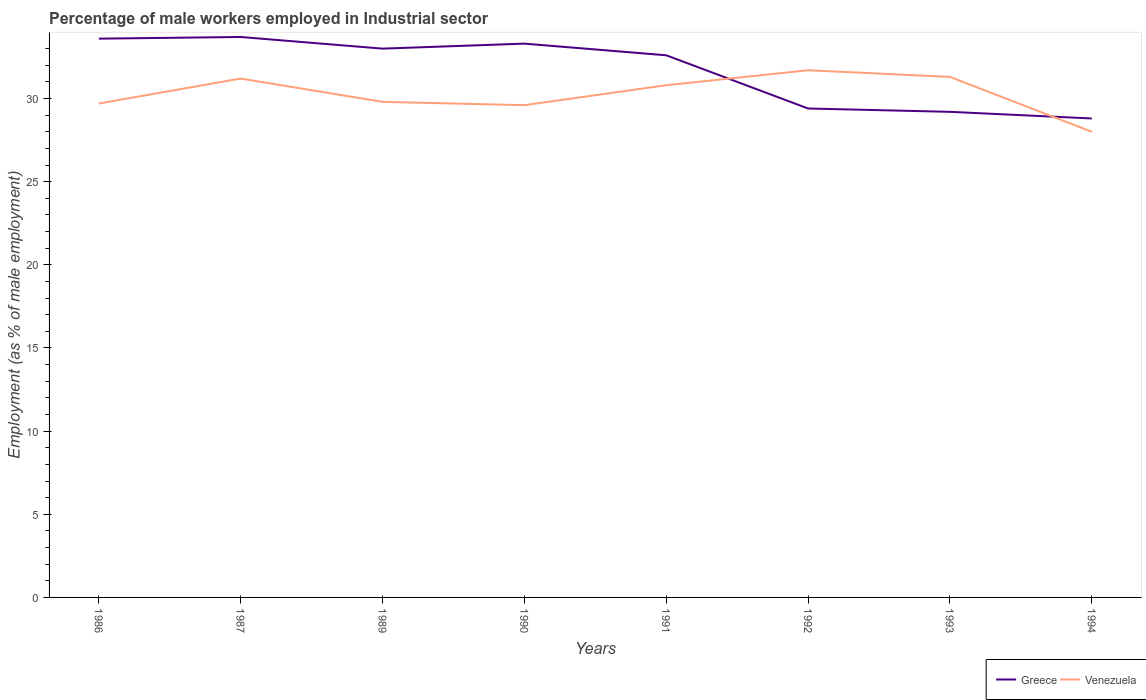Is the number of lines equal to the number of legend labels?
Offer a very short reply. Yes. Across all years, what is the maximum percentage of male workers employed in Industrial sector in Venezuela?
Offer a very short reply. 28. In which year was the percentage of male workers employed in Industrial sector in Greece maximum?
Offer a terse response. 1994. What is the total percentage of male workers employed in Industrial sector in Greece in the graph?
Provide a short and direct response. 0.7. What is the difference between the highest and the second highest percentage of male workers employed in Industrial sector in Venezuela?
Your answer should be very brief. 3.7. What is the difference between the highest and the lowest percentage of male workers employed in Industrial sector in Venezuela?
Provide a succinct answer. 4. Is the percentage of male workers employed in Industrial sector in Venezuela strictly greater than the percentage of male workers employed in Industrial sector in Greece over the years?
Provide a succinct answer. No. What is the difference between two consecutive major ticks on the Y-axis?
Keep it short and to the point. 5. Are the values on the major ticks of Y-axis written in scientific E-notation?
Offer a terse response. No. How many legend labels are there?
Make the answer very short. 2. How are the legend labels stacked?
Give a very brief answer. Horizontal. What is the title of the graph?
Provide a succinct answer. Percentage of male workers employed in Industrial sector. What is the label or title of the Y-axis?
Make the answer very short. Employment (as % of male employment). What is the Employment (as % of male employment) of Greece in 1986?
Your answer should be very brief. 33.6. What is the Employment (as % of male employment) of Venezuela in 1986?
Your answer should be compact. 29.7. What is the Employment (as % of male employment) of Greece in 1987?
Your answer should be compact. 33.7. What is the Employment (as % of male employment) of Venezuela in 1987?
Your answer should be compact. 31.2. What is the Employment (as % of male employment) of Greece in 1989?
Provide a short and direct response. 33. What is the Employment (as % of male employment) of Venezuela in 1989?
Give a very brief answer. 29.8. What is the Employment (as % of male employment) in Greece in 1990?
Keep it short and to the point. 33.3. What is the Employment (as % of male employment) in Venezuela in 1990?
Give a very brief answer. 29.6. What is the Employment (as % of male employment) of Greece in 1991?
Make the answer very short. 32.6. What is the Employment (as % of male employment) of Venezuela in 1991?
Your answer should be very brief. 30.8. What is the Employment (as % of male employment) of Greece in 1992?
Your response must be concise. 29.4. What is the Employment (as % of male employment) in Venezuela in 1992?
Ensure brevity in your answer.  31.7. What is the Employment (as % of male employment) of Greece in 1993?
Offer a very short reply. 29.2. What is the Employment (as % of male employment) in Venezuela in 1993?
Give a very brief answer. 31.3. What is the Employment (as % of male employment) in Greece in 1994?
Your response must be concise. 28.8. Across all years, what is the maximum Employment (as % of male employment) of Greece?
Keep it short and to the point. 33.7. Across all years, what is the maximum Employment (as % of male employment) of Venezuela?
Ensure brevity in your answer.  31.7. Across all years, what is the minimum Employment (as % of male employment) in Greece?
Offer a terse response. 28.8. What is the total Employment (as % of male employment) of Greece in the graph?
Ensure brevity in your answer.  253.6. What is the total Employment (as % of male employment) of Venezuela in the graph?
Provide a succinct answer. 242.1. What is the difference between the Employment (as % of male employment) in Venezuela in 1986 and that in 1987?
Your answer should be very brief. -1.5. What is the difference between the Employment (as % of male employment) in Venezuela in 1986 and that in 1989?
Offer a very short reply. -0.1. What is the difference between the Employment (as % of male employment) in Greece in 1986 and that in 1990?
Make the answer very short. 0.3. What is the difference between the Employment (as % of male employment) in Venezuela in 1986 and that in 1992?
Ensure brevity in your answer.  -2. What is the difference between the Employment (as % of male employment) of Greece in 1986 and that in 1993?
Provide a short and direct response. 4.4. What is the difference between the Employment (as % of male employment) in Greece in 1986 and that in 1994?
Your answer should be compact. 4.8. What is the difference between the Employment (as % of male employment) in Venezuela in 1986 and that in 1994?
Your response must be concise. 1.7. What is the difference between the Employment (as % of male employment) of Greece in 1987 and that in 1989?
Make the answer very short. 0.7. What is the difference between the Employment (as % of male employment) of Venezuela in 1987 and that in 1989?
Provide a short and direct response. 1.4. What is the difference between the Employment (as % of male employment) in Venezuela in 1987 and that in 1990?
Your answer should be compact. 1.6. What is the difference between the Employment (as % of male employment) of Greece in 1987 and that in 1991?
Ensure brevity in your answer.  1.1. What is the difference between the Employment (as % of male employment) of Venezuela in 1987 and that in 1991?
Offer a very short reply. 0.4. What is the difference between the Employment (as % of male employment) in Greece in 1987 and that in 1992?
Your answer should be compact. 4.3. What is the difference between the Employment (as % of male employment) of Venezuela in 1987 and that in 1992?
Keep it short and to the point. -0.5. What is the difference between the Employment (as % of male employment) of Venezuela in 1987 and that in 1993?
Offer a very short reply. -0.1. What is the difference between the Employment (as % of male employment) in Greece in 1987 and that in 1994?
Your response must be concise. 4.9. What is the difference between the Employment (as % of male employment) of Venezuela in 1989 and that in 1990?
Ensure brevity in your answer.  0.2. What is the difference between the Employment (as % of male employment) of Greece in 1989 and that in 1991?
Ensure brevity in your answer.  0.4. What is the difference between the Employment (as % of male employment) in Greece in 1989 and that in 1992?
Your answer should be very brief. 3.6. What is the difference between the Employment (as % of male employment) in Venezuela in 1989 and that in 1992?
Keep it short and to the point. -1.9. What is the difference between the Employment (as % of male employment) in Greece in 1989 and that in 1993?
Provide a succinct answer. 3.8. What is the difference between the Employment (as % of male employment) in Venezuela in 1989 and that in 1994?
Provide a succinct answer. 1.8. What is the difference between the Employment (as % of male employment) of Greece in 1990 and that in 1991?
Your answer should be very brief. 0.7. What is the difference between the Employment (as % of male employment) of Venezuela in 1990 and that in 1991?
Give a very brief answer. -1.2. What is the difference between the Employment (as % of male employment) of Greece in 1990 and that in 1992?
Ensure brevity in your answer.  3.9. What is the difference between the Employment (as % of male employment) in Greece in 1990 and that in 1993?
Keep it short and to the point. 4.1. What is the difference between the Employment (as % of male employment) in Venezuela in 1990 and that in 1993?
Provide a succinct answer. -1.7. What is the difference between the Employment (as % of male employment) of Greece in 1991 and that in 1992?
Offer a very short reply. 3.2. What is the difference between the Employment (as % of male employment) in Venezuela in 1991 and that in 1992?
Provide a short and direct response. -0.9. What is the difference between the Employment (as % of male employment) in Greece in 1991 and that in 1993?
Provide a succinct answer. 3.4. What is the difference between the Employment (as % of male employment) of Venezuela in 1991 and that in 1993?
Provide a short and direct response. -0.5. What is the difference between the Employment (as % of male employment) in Greece in 1992 and that in 1994?
Keep it short and to the point. 0.6. What is the difference between the Employment (as % of male employment) of Greece in 1993 and that in 1994?
Provide a succinct answer. 0.4. What is the difference between the Employment (as % of male employment) of Greece in 1986 and the Employment (as % of male employment) of Venezuela in 1987?
Your response must be concise. 2.4. What is the difference between the Employment (as % of male employment) of Greece in 1986 and the Employment (as % of male employment) of Venezuela in 1994?
Your answer should be compact. 5.6. What is the difference between the Employment (as % of male employment) of Greece in 1987 and the Employment (as % of male employment) of Venezuela in 1989?
Offer a terse response. 3.9. What is the difference between the Employment (as % of male employment) in Greece in 1987 and the Employment (as % of male employment) in Venezuela in 1991?
Offer a terse response. 2.9. What is the difference between the Employment (as % of male employment) of Greece in 1987 and the Employment (as % of male employment) of Venezuela in 1992?
Ensure brevity in your answer.  2. What is the difference between the Employment (as % of male employment) in Greece in 1987 and the Employment (as % of male employment) in Venezuela in 1993?
Your answer should be very brief. 2.4. What is the difference between the Employment (as % of male employment) of Greece in 1989 and the Employment (as % of male employment) of Venezuela in 1990?
Offer a terse response. 3.4. What is the difference between the Employment (as % of male employment) of Greece in 1989 and the Employment (as % of male employment) of Venezuela in 1991?
Your answer should be very brief. 2.2. What is the difference between the Employment (as % of male employment) in Greece in 1989 and the Employment (as % of male employment) in Venezuela in 1992?
Offer a very short reply. 1.3. What is the difference between the Employment (as % of male employment) in Greece in 1989 and the Employment (as % of male employment) in Venezuela in 1993?
Offer a very short reply. 1.7. What is the difference between the Employment (as % of male employment) of Greece in 1990 and the Employment (as % of male employment) of Venezuela in 1991?
Offer a terse response. 2.5. What is the difference between the Employment (as % of male employment) of Greece in 1990 and the Employment (as % of male employment) of Venezuela in 1994?
Make the answer very short. 5.3. What is the difference between the Employment (as % of male employment) in Greece in 1991 and the Employment (as % of male employment) in Venezuela in 1992?
Give a very brief answer. 0.9. What is the difference between the Employment (as % of male employment) of Greece in 1991 and the Employment (as % of male employment) of Venezuela in 1993?
Give a very brief answer. 1.3. What is the difference between the Employment (as % of male employment) of Greece in 1991 and the Employment (as % of male employment) of Venezuela in 1994?
Provide a short and direct response. 4.6. What is the difference between the Employment (as % of male employment) of Greece in 1992 and the Employment (as % of male employment) of Venezuela in 1993?
Ensure brevity in your answer.  -1.9. What is the average Employment (as % of male employment) of Greece per year?
Provide a short and direct response. 31.7. What is the average Employment (as % of male employment) in Venezuela per year?
Make the answer very short. 30.26. In the year 1986, what is the difference between the Employment (as % of male employment) in Greece and Employment (as % of male employment) in Venezuela?
Keep it short and to the point. 3.9. In the year 1989, what is the difference between the Employment (as % of male employment) in Greece and Employment (as % of male employment) in Venezuela?
Make the answer very short. 3.2. In the year 1991, what is the difference between the Employment (as % of male employment) in Greece and Employment (as % of male employment) in Venezuela?
Provide a short and direct response. 1.8. In the year 1994, what is the difference between the Employment (as % of male employment) in Greece and Employment (as % of male employment) in Venezuela?
Keep it short and to the point. 0.8. What is the ratio of the Employment (as % of male employment) in Greece in 1986 to that in 1987?
Your answer should be compact. 1. What is the ratio of the Employment (as % of male employment) of Venezuela in 1986 to that in 1987?
Give a very brief answer. 0.95. What is the ratio of the Employment (as % of male employment) in Greece in 1986 to that in 1989?
Give a very brief answer. 1.02. What is the ratio of the Employment (as % of male employment) in Greece in 1986 to that in 1990?
Make the answer very short. 1.01. What is the ratio of the Employment (as % of male employment) in Venezuela in 1986 to that in 1990?
Offer a terse response. 1. What is the ratio of the Employment (as % of male employment) in Greece in 1986 to that in 1991?
Provide a short and direct response. 1.03. What is the ratio of the Employment (as % of male employment) in Venezuela in 1986 to that in 1991?
Offer a terse response. 0.96. What is the ratio of the Employment (as % of male employment) of Greece in 1986 to that in 1992?
Your answer should be compact. 1.14. What is the ratio of the Employment (as % of male employment) of Venezuela in 1986 to that in 1992?
Keep it short and to the point. 0.94. What is the ratio of the Employment (as % of male employment) of Greece in 1986 to that in 1993?
Ensure brevity in your answer.  1.15. What is the ratio of the Employment (as % of male employment) in Venezuela in 1986 to that in 1993?
Give a very brief answer. 0.95. What is the ratio of the Employment (as % of male employment) of Venezuela in 1986 to that in 1994?
Your answer should be very brief. 1.06. What is the ratio of the Employment (as % of male employment) in Greece in 1987 to that in 1989?
Give a very brief answer. 1.02. What is the ratio of the Employment (as % of male employment) of Venezuela in 1987 to that in 1989?
Your answer should be compact. 1.05. What is the ratio of the Employment (as % of male employment) in Greece in 1987 to that in 1990?
Your answer should be compact. 1.01. What is the ratio of the Employment (as % of male employment) in Venezuela in 1987 to that in 1990?
Your answer should be very brief. 1.05. What is the ratio of the Employment (as % of male employment) of Greece in 1987 to that in 1991?
Ensure brevity in your answer.  1.03. What is the ratio of the Employment (as % of male employment) in Greece in 1987 to that in 1992?
Your answer should be compact. 1.15. What is the ratio of the Employment (as % of male employment) in Venezuela in 1987 to that in 1992?
Ensure brevity in your answer.  0.98. What is the ratio of the Employment (as % of male employment) in Greece in 1987 to that in 1993?
Your answer should be very brief. 1.15. What is the ratio of the Employment (as % of male employment) of Venezuela in 1987 to that in 1993?
Keep it short and to the point. 1. What is the ratio of the Employment (as % of male employment) in Greece in 1987 to that in 1994?
Offer a very short reply. 1.17. What is the ratio of the Employment (as % of male employment) in Venezuela in 1987 to that in 1994?
Give a very brief answer. 1.11. What is the ratio of the Employment (as % of male employment) in Venezuela in 1989 to that in 1990?
Your answer should be very brief. 1.01. What is the ratio of the Employment (as % of male employment) in Greece in 1989 to that in 1991?
Ensure brevity in your answer.  1.01. What is the ratio of the Employment (as % of male employment) of Venezuela in 1989 to that in 1991?
Your response must be concise. 0.97. What is the ratio of the Employment (as % of male employment) of Greece in 1989 to that in 1992?
Provide a short and direct response. 1.12. What is the ratio of the Employment (as % of male employment) of Venezuela in 1989 to that in 1992?
Provide a short and direct response. 0.94. What is the ratio of the Employment (as % of male employment) of Greece in 1989 to that in 1993?
Offer a very short reply. 1.13. What is the ratio of the Employment (as % of male employment) of Venezuela in 1989 to that in 1993?
Make the answer very short. 0.95. What is the ratio of the Employment (as % of male employment) in Greece in 1989 to that in 1994?
Provide a short and direct response. 1.15. What is the ratio of the Employment (as % of male employment) in Venezuela in 1989 to that in 1994?
Ensure brevity in your answer.  1.06. What is the ratio of the Employment (as % of male employment) in Greece in 1990 to that in 1991?
Offer a very short reply. 1.02. What is the ratio of the Employment (as % of male employment) in Venezuela in 1990 to that in 1991?
Your answer should be compact. 0.96. What is the ratio of the Employment (as % of male employment) in Greece in 1990 to that in 1992?
Your response must be concise. 1.13. What is the ratio of the Employment (as % of male employment) in Venezuela in 1990 to that in 1992?
Your answer should be very brief. 0.93. What is the ratio of the Employment (as % of male employment) of Greece in 1990 to that in 1993?
Keep it short and to the point. 1.14. What is the ratio of the Employment (as % of male employment) of Venezuela in 1990 to that in 1993?
Your answer should be very brief. 0.95. What is the ratio of the Employment (as % of male employment) in Greece in 1990 to that in 1994?
Offer a very short reply. 1.16. What is the ratio of the Employment (as % of male employment) of Venezuela in 1990 to that in 1994?
Your answer should be very brief. 1.06. What is the ratio of the Employment (as % of male employment) in Greece in 1991 to that in 1992?
Ensure brevity in your answer.  1.11. What is the ratio of the Employment (as % of male employment) of Venezuela in 1991 to that in 1992?
Offer a terse response. 0.97. What is the ratio of the Employment (as % of male employment) of Greece in 1991 to that in 1993?
Your answer should be very brief. 1.12. What is the ratio of the Employment (as % of male employment) in Venezuela in 1991 to that in 1993?
Your answer should be very brief. 0.98. What is the ratio of the Employment (as % of male employment) of Greece in 1991 to that in 1994?
Offer a terse response. 1.13. What is the ratio of the Employment (as % of male employment) of Venezuela in 1991 to that in 1994?
Your response must be concise. 1.1. What is the ratio of the Employment (as % of male employment) in Greece in 1992 to that in 1993?
Your answer should be very brief. 1.01. What is the ratio of the Employment (as % of male employment) in Venezuela in 1992 to that in 1993?
Give a very brief answer. 1.01. What is the ratio of the Employment (as % of male employment) in Greece in 1992 to that in 1994?
Keep it short and to the point. 1.02. What is the ratio of the Employment (as % of male employment) in Venezuela in 1992 to that in 1994?
Provide a succinct answer. 1.13. What is the ratio of the Employment (as % of male employment) of Greece in 1993 to that in 1994?
Keep it short and to the point. 1.01. What is the ratio of the Employment (as % of male employment) in Venezuela in 1993 to that in 1994?
Your response must be concise. 1.12. What is the difference between the highest and the second highest Employment (as % of male employment) of Greece?
Your answer should be compact. 0.1. What is the difference between the highest and the lowest Employment (as % of male employment) in Venezuela?
Ensure brevity in your answer.  3.7. 